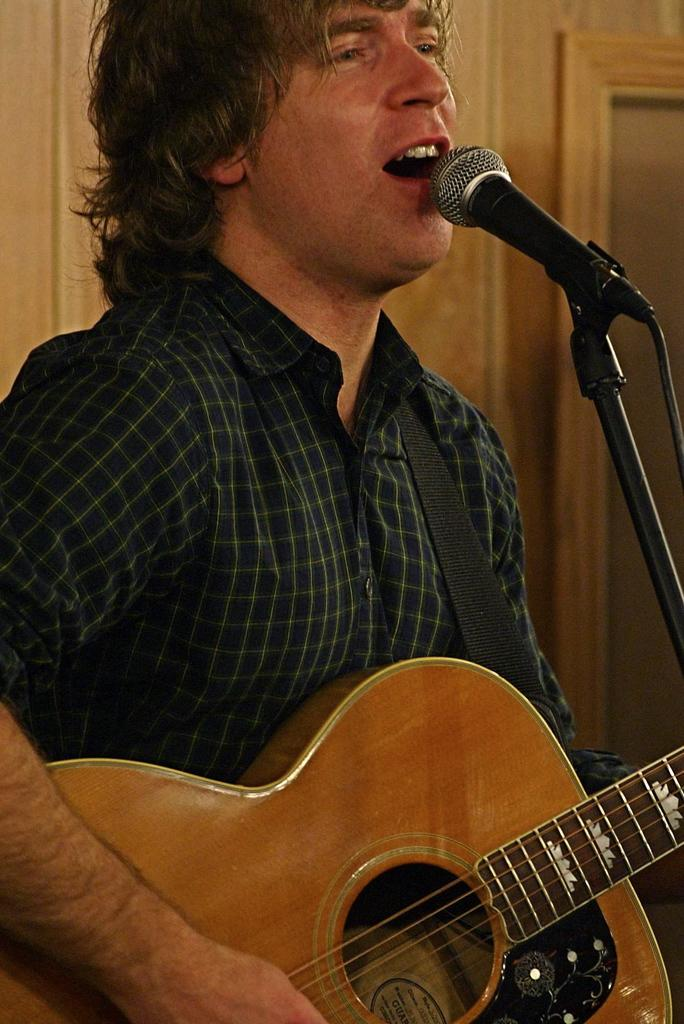What is the man in the image doing? The man is holding a guitar and singing a song. What object is in front of the man? There is a microphone with a stand in front of the man. What can be seen in the background of the image? The background of the image features a wooden wall. Can you tell me how many bees are buzzing around the man in the image? There are no bees present in the image; the man is singing with a guitar and a microphone in front of him. 